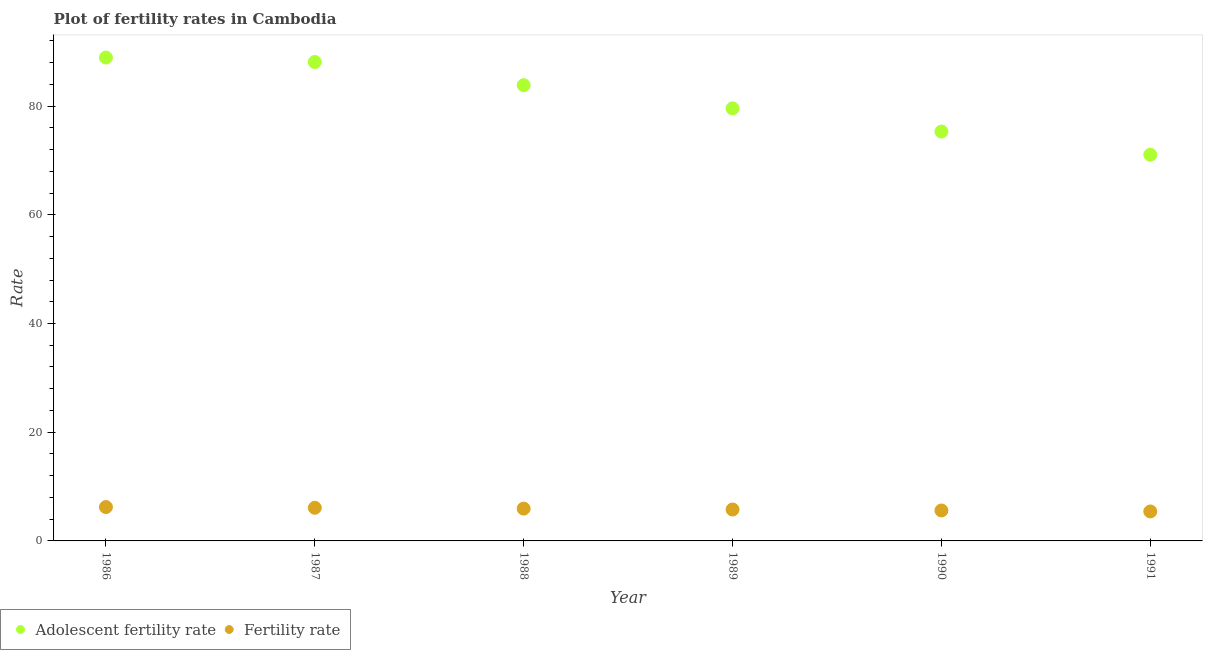Is the number of dotlines equal to the number of legend labels?
Your answer should be very brief. Yes. What is the fertility rate in 1986?
Provide a short and direct response. 6.23. Across all years, what is the maximum fertility rate?
Your answer should be compact. 6.23. Across all years, what is the minimum adolescent fertility rate?
Provide a short and direct response. 71.05. In which year was the fertility rate maximum?
Make the answer very short. 1986. In which year was the fertility rate minimum?
Provide a succinct answer. 1991. What is the total fertility rate in the graph?
Provide a short and direct response. 35.07. What is the difference between the fertility rate in 1986 and that in 1990?
Offer a terse response. 0.62. What is the difference between the adolescent fertility rate in 1989 and the fertility rate in 1986?
Offer a very short reply. 73.35. What is the average fertility rate per year?
Your answer should be very brief. 5.84. In the year 1988, what is the difference between the fertility rate and adolescent fertility rate?
Offer a very short reply. -77.9. What is the ratio of the adolescent fertility rate in 1987 to that in 1988?
Ensure brevity in your answer.  1.05. What is the difference between the highest and the second highest adolescent fertility rate?
Provide a succinct answer. 0.82. What is the difference between the highest and the lowest fertility rate?
Give a very brief answer. 0.8. Is the fertility rate strictly less than the adolescent fertility rate over the years?
Offer a terse response. Yes. How many years are there in the graph?
Your answer should be very brief. 6. What is the difference between two consecutive major ticks on the Y-axis?
Offer a terse response. 20. Are the values on the major ticks of Y-axis written in scientific E-notation?
Make the answer very short. No. Does the graph contain grids?
Your answer should be compact. No. What is the title of the graph?
Offer a terse response. Plot of fertility rates in Cambodia. Does "Under-5(female)" appear as one of the legend labels in the graph?
Offer a terse response. No. What is the label or title of the Y-axis?
Make the answer very short. Rate. What is the Rate in Adolescent fertility rate in 1986?
Offer a very short reply. 88.92. What is the Rate in Fertility rate in 1986?
Provide a short and direct response. 6.23. What is the Rate in Adolescent fertility rate in 1987?
Provide a short and direct response. 88.11. What is the Rate in Fertility rate in 1987?
Provide a short and direct response. 6.1. What is the Rate of Adolescent fertility rate in 1988?
Keep it short and to the point. 83.84. What is the Rate of Fertility rate in 1988?
Keep it short and to the point. 5.94. What is the Rate of Adolescent fertility rate in 1989?
Provide a succinct answer. 79.58. What is the Rate in Fertility rate in 1989?
Keep it short and to the point. 5.78. What is the Rate of Adolescent fertility rate in 1990?
Provide a succinct answer. 75.31. What is the Rate of Fertility rate in 1990?
Provide a short and direct response. 5.6. What is the Rate in Adolescent fertility rate in 1991?
Ensure brevity in your answer.  71.05. What is the Rate in Fertility rate in 1991?
Your response must be concise. 5.42. Across all years, what is the maximum Rate in Adolescent fertility rate?
Provide a short and direct response. 88.92. Across all years, what is the maximum Rate in Fertility rate?
Keep it short and to the point. 6.23. Across all years, what is the minimum Rate in Adolescent fertility rate?
Make the answer very short. 71.05. Across all years, what is the minimum Rate in Fertility rate?
Keep it short and to the point. 5.42. What is the total Rate of Adolescent fertility rate in the graph?
Provide a succinct answer. 486.81. What is the total Rate in Fertility rate in the graph?
Provide a short and direct response. 35.07. What is the difference between the Rate in Adolescent fertility rate in 1986 and that in 1987?
Offer a very short reply. 0.82. What is the difference between the Rate in Fertility rate in 1986 and that in 1987?
Provide a short and direct response. 0.13. What is the difference between the Rate in Adolescent fertility rate in 1986 and that in 1988?
Make the answer very short. 5.08. What is the difference between the Rate of Fertility rate in 1986 and that in 1988?
Offer a very short reply. 0.28. What is the difference between the Rate in Adolescent fertility rate in 1986 and that in 1989?
Your answer should be very brief. 9.35. What is the difference between the Rate of Fertility rate in 1986 and that in 1989?
Offer a terse response. 0.45. What is the difference between the Rate in Adolescent fertility rate in 1986 and that in 1990?
Your response must be concise. 13.61. What is the difference between the Rate of Adolescent fertility rate in 1986 and that in 1991?
Keep it short and to the point. 17.88. What is the difference between the Rate of Fertility rate in 1986 and that in 1991?
Keep it short and to the point. 0.81. What is the difference between the Rate of Adolescent fertility rate in 1987 and that in 1988?
Your answer should be very brief. 4.27. What is the difference between the Rate of Fertility rate in 1987 and that in 1988?
Your response must be concise. 0.15. What is the difference between the Rate of Adolescent fertility rate in 1987 and that in 1989?
Make the answer very short. 8.53. What is the difference between the Rate in Fertility rate in 1987 and that in 1989?
Provide a short and direct response. 0.32. What is the difference between the Rate of Adolescent fertility rate in 1987 and that in 1990?
Provide a short and direct response. 12.8. What is the difference between the Rate in Fertility rate in 1987 and that in 1990?
Ensure brevity in your answer.  0.5. What is the difference between the Rate in Adolescent fertility rate in 1987 and that in 1991?
Give a very brief answer. 17.06. What is the difference between the Rate of Fertility rate in 1987 and that in 1991?
Your answer should be compact. 0.68. What is the difference between the Rate in Adolescent fertility rate in 1988 and that in 1989?
Your answer should be compact. 4.27. What is the difference between the Rate in Fertility rate in 1988 and that in 1989?
Make the answer very short. 0.17. What is the difference between the Rate in Adolescent fertility rate in 1988 and that in 1990?
Give a very brief answer. 8.53. What is the difference between the Rate of Fertility rate in 1988 and that in 1990?
Provide a succinct answer. 0.34. What is the difference between the Rate of Adolescent fertility rate in 1988 and that in 1991?
Provide a short and direct response. 12.8. What is the difference between the Rate of Fertility rate in 1988 and that in 1991?
Your answer should be very brief. 0.52. What is the difference between the Rate of Adolescent fertility rate in 1989 and that in 1990?
Offer a very short reply. 4.27. What is the difference between the Rate in Fertility rate in 1989 and that in 1990?
Ensure brevity in your answer.  0.18. What is the difference between the Rate of Adolescent fertility rate in 1989 and that in 1991?
Your response must be concise. 8.53. What is the difference between the Rate of Fertility rate in 1989 and that in 1991?
Offer a terse response. 0.36. What is the difference between the Rate in Adolescent fertility rate in 1990 and that in 1991?
Make the answer very short. 4.27. What is the difference between the Rate of Fertility rate in 1990 and that in 1991?
Offer a very short reply. 0.18. What is the difference between the Rate of Adolescent fertility rate in 1986 and the Rate of Fertility rate in 1987?
Your response must be concise. 82.83. What is the difference between the Rate in Adolescent fertility rate in 1986 and the Rate in Fertility rate in 1988?
Give a very brief answer. 82.98. What is the difference between the Rate of Adolescent fertility rate in 1986 and the Rate of Fertility rate in 1989?
Give a very brief answer. 83.15. What is the difference between the Rate in Adolescent fertility rate in 1986 and the Rate in Fertility rate in 1990?
Your answer should be very brief. 83.32. What is the difference between the Rate of Adolescent fertility rate in 1986 and the Rate of Fertility rate in 1991?
Provide a succinct answer. 83.5. What is the difference between the Rate of Adolescent fertility rate in 1987 and the Rate of Fertility rate in 1988?
Keep it short and to the point. 82.16. What is the difference between the Rate in Adolescent fertility rate in 1987 and the Rate in Fertility rate in 1989?
Your answer should be very brief. 82.33. What is the difference between the Rate in Adolescent fertility rate in 1987 and the Rate in Fertility rate in 1990?
Offer a terse response. 82.51. What is the difference between the Rate in Adolescent fertility rate in 1987 and the Rate in Fertility rate in 1991?
Keep it short and to the point. 82.69. What is the difference between the Rate of Adolescent fertility rate in 1988 and the Rate of Fertility rate in 1989?
Your answer should be compact. 78.06. What is the difference between the Rate of Adolescent fertility rate in 1988 and the Rate of Fertility rate in 1990?
Offer a terse response. 78.24. What is the difference between the Rate in Adolescent fertility rate in 1988 and the Rate in Fertility rate in 1991?
Keep it short and to the point. 78.42. What is the difference between the Rate of Adolescent fertility rate in 1989 and the Rate of Fertility rate in 1990?
Offer a very short reply. 73.98. What is the difference between the Rate in Adolescent fertility rate in 1989 and the Rate in Fertility rate in 1991?
Make the answer very short. 74.16. What is the difference between the Rate of Adolescent fertility rate in 1990 and the Rate of Fertility rate in 1991?
Provide a short and direct response. 69.89. What is the average Rate of Adolescent fertility rate per year?
Keep it short and to the point. 81.13. What is the average Rate in Fertility rate per year?
Keep it short and to the point. 5.84. In the year 1986, what is the difference between the Rate in Adolescent fertility rate and Rate in Fertility rate?
Ensure brevity in your answer.  82.7. In the year 1987, what is the difference between the Rate of Adolescent fertility rate and Rate of Fertility rate?
Provide a short and direct response. 82.01. In the year 1988, what is the difference between the Rate in Adolescent fertility rate and Rate in Fertility rate?
Your response must be concise. 77.9. In the year 1989, what is the difference between the Rate in Adolescent fertility rate and Rate in Fertility rate?
Provide a succinct answer. 73.8. In the year 1990, what is the difference between the Rate of Adolescent fertility rate and Rate of Fertility rate?
Give a very brief answer. 69.71. In the year 1991, what is the difference between the Rate of Adolescent fertility rate and Rate of Fertility rate?
Offer a terse response. 65.63. What is the ratio of the Rate of Adolescent fertility rate in 1986 to that in 1987?
Provide a short and direct response. 1.01. What is the ratio of the Rate in Fertility rate in 1986 to that in 1987?
Your response must be concise. 1.02. What is the ratio of the Rate in Adolescent fertility rate in 1986 to that in 1988?
Offer a very short reply. 1.06. What is the ratio of the Rate of Fertility rate in 1986 to that in 1988?
Ensure brevity in your answer.  1.05. What is the ratio of the Rate in Adolescent fertility rate in 1986 to that in 1989?
Keep it short and to the point. 1.12. What is the ratio of the Rate of Fertility rate in 1986 to that in 1989?
Provide a short and direct response. 1.08. What is the ratio of the Rate in Adolescent fertility rate in 1986 to that in 1990?
Provide a short and direct response. 1.18. What is the ratio of the Rate in Fertility rate in 1986 to that in 1990?
Keep it short and to the point. 1.11. What is the ratio of the Rate in Adolescent fertility rate in 1986 to that in 1991?
Make the answer very short. 1.25. What is the ratio of the Rate of Fertility rate in 1986 to that in 1991?
Offer a very short reply. 1.15. What is the ratio of the Rate in Adolescent fertility rate in 1987 to that in 1988?
Your answer should be compact. 1.05. What is the ratio of the Rate in Fertility rate in 1987 to that in 1988?
Provide a short and direct response. 1.03. What is the ratio of the Rate in Adolescent fertility rate in 1987 to that in 1989?
Your answer should be very brief. 1.11. What is the ratio of the Rate of Fertility rate in 1987 to that in 1989?
Keep it short and to the point. 1.06. What is the ratio of the Rate of Adolescent fertility rate in 1987 to that in 1990?
Give a very brief answer. 1.17. What is the ratio of the Rate in Fertility rate in 1987 to that in 1990?
Provide a succinct answer. 1.09. What is the ratio of the Rate of Adolescent fertility rate in 1987 to that in 1991?
Your answer should be very brief. 1.24. What is the ratio of the Rate in Fertility rate in 1987 to that in 1991?
Offer a very short reply. 1.12. What is the ratio of the Rate of Adolescent fertility rate in 1988 to that in 1989?
Provide a succinct answer. 1.05. What is the ratio of the Rate in Fertility rate in 1988 to that in 1989?
Offer a terse response. 1.03. What is the ratio of the Rate of Adolescent fertility rate in 1988 to that in 1990?
Provide a succinct answer. 1.11. What is the ratio of the Rate in Fertility rate in 1988 to that in 1990?
Your response must be concise. 1.06. What is the ratio of the Rate in Adolescent fertility rate in 1988 to that in 1991?
Provide a succinct answer. 1.18. What is the ratio of the Rate of Fertility rate in 1988 to that in 1991?
Offer a very short reply. 1.1. What is the ratio of the Rate of Adolescent fertility rate in 1989 to that in 1990?
Make the answer very short. 1.06. What is the ratio of the Rate of Fertility rate in 1989 to that in 1990?
Your answer should be very brief. 1.03. What is the ratio of the Rate in Adolescent fertility rate in 1989 to that in 1991?
Keep it short and to the point. 1.12. What is the ratio of the Rate in Fertility rate in 1989 to that in 1991?
Offer a terse response. 1.07. What is the ratio of the Rate in Adolescent fertility rate in 1990 to that in 1991?
Your answer should be compact. 1.06. What is the ratio of the Rate in Fertility rate in 1990 to that in 1991?
Give a very brief answer. 1.03. What is the difference between the highest and the second highest Rate of Adolescent fertility rate?
Provide a short and direct response. 0.82. What is the difference between the highest and the second highest Rate in Fertility rate?
Your response must be concise. 0.13. What is the difference between the highest and the lowest Rate in Adolescent fertility rate?
Make the answer very short. 17.88. What is the difference between the highest and the lowest Rate in Fertility rate?
Ensure brevity in your answer.  0.81. 